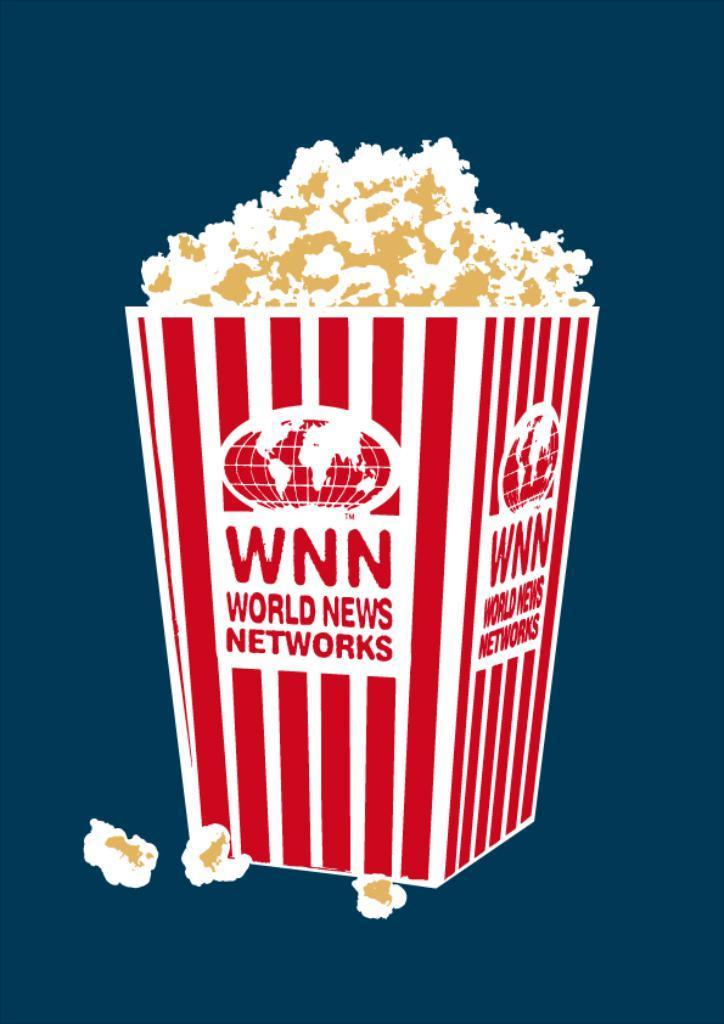Describe this image in one or two sentences. In this image, there is a popcorn on the blue background. 